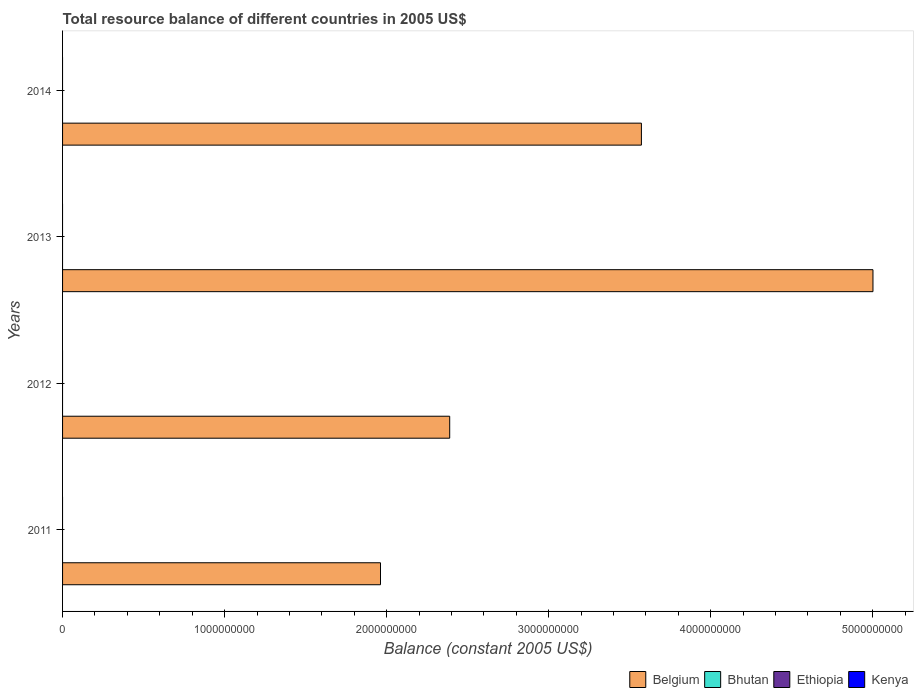How many different coloured bars are there?
Make the answer very short. 1. Are the number of bars on each tick of the Y-axis equal?
Offer a very short reply. Yes. In how many cases, is the number of bars for a given year not equal to the number of legend labels?
Offer a very short reply. 4. What is the total resource balance in Belgium in 2014?
Make the answer very short. 3.57e+09. Across all years, what is the minimum total resource balance in Belgium?
Offer a terse response. 1.96e+09. In which year was the total resource balance in Belgium maximum?
Your answer should be compact. 2013. What is the difference between the total resource balance in Belgium in 2012 and that in 2013?
Your answer should be very brief. -2.61e+09. What is the difference between the total resource balance in Bhutan in 2011 and the total resource balance in Belgium in 2012?
Your answer should be compact. -2.39e+09. What is the average total resource balance in Ethiopia per year?
Your answer should be compact. 0. What is the ratio of the total resource balance in Belgium in 2011 to that in 2014?
Offer a terse response. 0.55. Is the total resource balance in Belgium in 2012 less than that in 2013?
Offer a terse response. Yes. What is the difference between the highest and the second highest total resource balance in Belgium?
Provide a succinct answer. 1.43e+09. Is it the case that in every year, the sum of the total resource balance in Ethiopia and total resource balance in Bhutan is greater than the sum of total resource balance in Belgium and total resource balance in Kenya?
Give a very brief answer. No. How many years are there in the graph?
Give a very brief answer. 4. How are the legend labels stacked?
Your response must be concise. Horizontal. What is the title of the graph?
Provide a succinct answer. Total resource balance of different countries in 2005 US$. What is the label or title of the X-axis?
Keep it short and to the point. Balance (constant 2005 US$). What is the label or title of the Y-axis?
Offer a very short reply. Years. What is the Balance (constant 2005 US$) in Belgium in 2011?
Make the answer very short. 1.96e+09. What is the Balance (constant 2005 US$) in Bhutan in 2011?
Make the answer very short. 0. What is the Balance (constant 2005 US$) of Kenya in 2011?
Your answer should be compact. 0. What is the Balance (constant 2005 US$) of Belgium in 2012?
Offer a terse response. 2.39e+09. What is the Balance (constant 2005 US$) of Ethiopia in 2012?
Keep it short and to the point. 0. What is the Balance (constant 2005 US$) in Belgium in 2013?
Offer a very short reply. 5.00e+09. What is the Balance (constant 2005 US$) of Ethiopia in 2013?
Your answer should be very brief. 0. What is the Balance (constant 2005 US$) in Kenya in 2013?
Provide a succinct answer. 0. What is the Balance (constant 2005 US$) in Belgium in 2014?
Keep it short and to the point. 3.57e+09. Across all years, what is the maximum Balance (constant 2005 US$) in Belgium?
Keep it short and to the point. 5.00e+09. Across all years, what is the minimum Balance (constant 2005 US$) in Belgium?
Your answer should be very brief. 1.96e+09. What is the total Balance (constant 2005 US$) of Belgium in the graph?
Keep it short and to the point. 1.29e+1. What is the difference between the Balance (constant 2005 US$) of Belgium in 2011 and that in 2012?
Ensure brevity in your answer.  -4.27e+08. What is the difference between the Balance (constant 2005 US$) of Belgium in 2011 and that in 2013?
Provide a succinct answer. -3.04e+09. What is the difference between the Balance (constant 2005 US$) in Belgium in 2011 and that in 2014?
Keep it short and to the point. -1.61e+09. What is the difference between the Balance (constant 2005 US$) of Belgium in 2012 and that in 2013?
Your answer should be compact. -2.61e+09. What is the difference between the Balance (constant 2005 US$) of Belgium in 2012 and that in 2014?
Offer a terse response. -1.18e+09. What is the difference between the Balance (constant 2005 US$) of Belgium in 2013 and that in 2014?
Your response must be concise. 1.43e+09. What is the average Balance (constant 2005 US$) of Belgium per year?
Your answer should be compact. 3.23e+09. What is the average Balance (constant 2005 US$) of Bhutan per year?
Your response must be concise. 0. What is the average Balance (constant 2005 US$) of Ethiopia per year?
Keep it short and to the point. 0. What is the average Balance (constant 2005 US$) of Kenya per year?
Keep it short and to the point. 0. What is the ratio of the Balance (constant 2005 US$) of Belgium in 2011 to that in 2012?
Provide a short and direct response. 0.82. What is the ratio of the Balance (constant 2005 US$) in Belgium in 2011 to that in 2013?
Offer a very short reply. 0.39. What is the ratio of the Balance (constant 2005 US$) in Belgium in 2011 to that in 2014?
Make the answer very short. 0.55. What is the ratio of the Balance (constant 2005 US$) in Belgium in 2012 to that in 2013?
Give a very brief answer. 0.48. What is the ratio of the Balance (constant 2005 US$) in Belgium in 2012 to that in 2014?
Offer a very short reply. 0.67. What is the ratio of the Balance (constant 2005 US$) of Belgium in 2013 to that in 2014?
Provide a succinct answer. 1.4. What is the difference between the highest and the second highest Balance (constant 2005 US$) of Belgium?
Your answer should be very brief. 1.43e+09. What is the difference between the highest and the lowest Balance (constant 2005 US$) in Belgium?
Offer a terse response. 3.04e+09. 